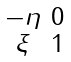<formula> <loc_0><loc_0><loc_500><loc_500>\begin{smallmatrix} - \eta & 0 \\ \xi & 1 \end{smallmatrix}</formula> 